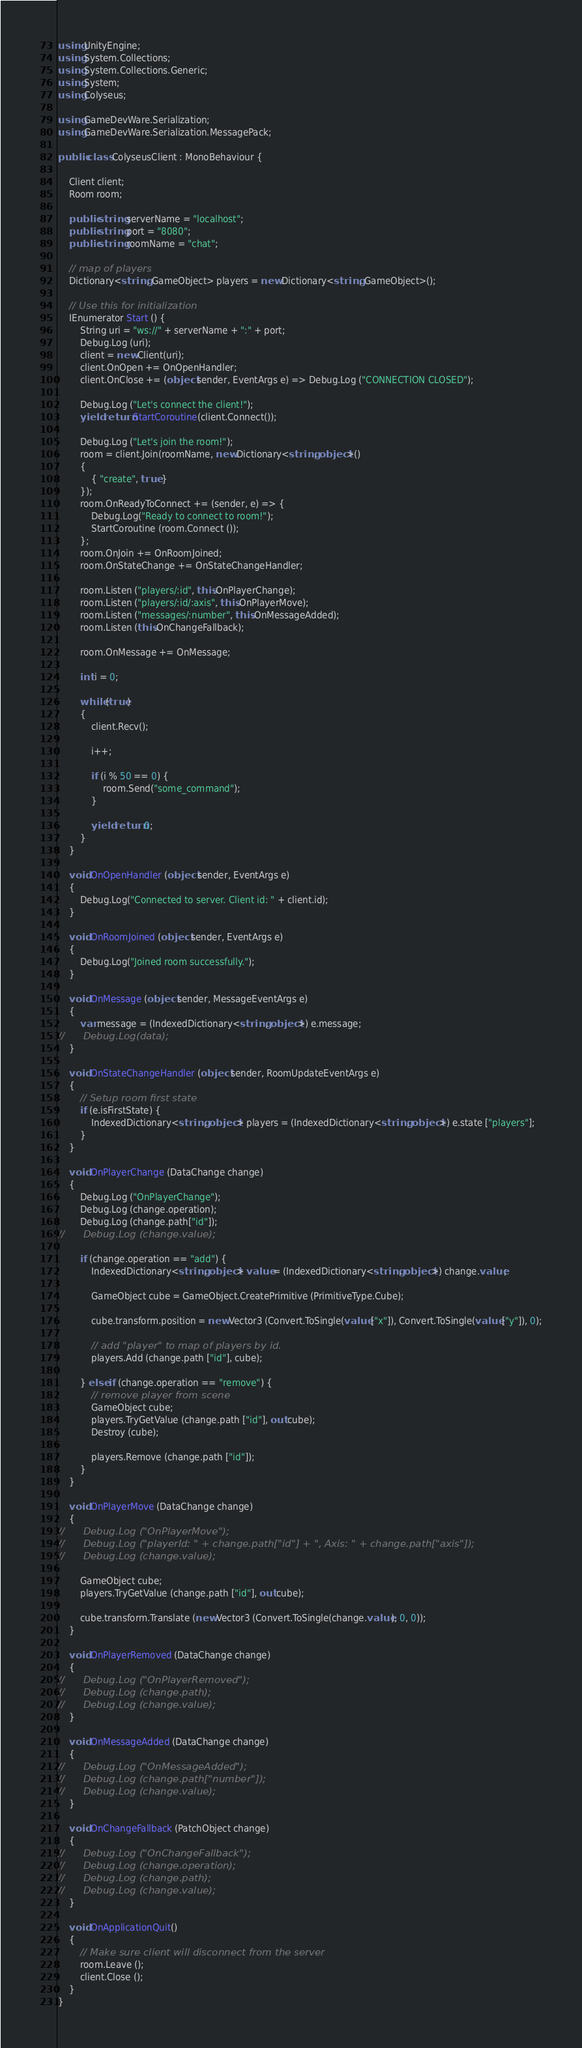Convert code to text. <code><loc_0><loc_0><loc_500><loc_500><_C#_>using UnityEngine;
using System.Collections;
using System.Collections.Generic;
using System;
using Colyseus;

using GameDevWare.Serialization;
using GameDevWare.Serialization.MessagePack;

public class ColyseusClient : MonoBehaviour {

	Client client;
	Room room;

	public string serverName = "localhost";
	public string port = "8080";
	public string roomName = "chat";

	// map of players
	Dictionary<string, GameObject> players = new Dictionary<string, GameObject>();

	// Use this for initialization
	IEnumerator Start () {
		String uri = "ws://" + serverName + ":" + port;
		Debug.Log (uri);
		client = new Client(uri);
		client.OnOpen += OnOpenHandler;
		client.OnClose += (object sender, EventArgs e) => Debug.Log ("CONNECTION CLOSED");

		Debug.Log ("Let's connect the client!");
		yield return StartCoroutine(client.Connect());

		Debug.Log ("Let's join the room!");
		room = client.Join(roomName, new Dictionary<string, object>()
		{
			{ "create", true }
		});
		room.OnReadyToConnect += (sender, e) => {
			Debug.Log("Ready to connect to room!");
			StartCoroutine (room.Connect ());
		};
		room.OnJoin += OnRoomJoined;
		room.OnStateChange += OnStateChangeHandler;

		room.Listen ("players/:id", this.OnPlayerChange);
		room.Listen ("players/:id/:axis", this.OnPlayerMove);
		room.Listen ("messages/:number", this.OnMessageAdded);
		room.Listen (this.OnChangeFallback);

		room.OnMessage += OnMessage;

		int i = 0;

		while (true)
		{
			client.Recv();

			i++;

			if (i % 50 == 0) {
				room.Send("some_command");
			}

			yield return 0;
		}
	}

	void OnOpenHandler (object sender, EventArgs e)
	{
		Debug.Log("Connected to server. Client id: " + client.id);
	}

	void OnRoomJoined (object sender, EventArgs e)
	{
		Debug.Log("Joined room successfully.");
	}

	void OnMessage (object sender, MessageEventArgs e)
	{
		var message = (IndexedDictionary<string, object>) e.message;
//		Debug.Log(data);
	}

	void OnStateChangeHandler (object sender, RoomUpdateEventArgs e)
	{
		// Setup room first state
		if (e.isFirstState) {
			IndexedDictionary<string, object> players = (IndexedDictionary<string, object>) e.state ["players"];
		}
	}

	void OnPlayerChange (DataChange change)
	{
		Debug.Log ("OnPlayerChange");
		Debug.Log (change.operation);
		Debug.Log (change.path["id"]);
//		Debug.Log (change.value);

		if (change.operation == "add") {
			IndexedDictionary<string, object> value = (IndexedDictionary<string, object>) change.value;

			GameObject cube = GameObject.CreatePrimitive (PrimitiveType.Cube);

			cube.transform.position = new Vector3 (Convert.ToSingle(value ["x"]), Convert.ToSingle(value ["y"]), 0);

			// add "player" to map of players by id.
			players.Add (change.path ["id"], cube);

		} else if (change.operation == "remove") {
			// remove player from scene
			GameObject cube;
			players.TryGetValue (change.path ["id"], out cube);
			Destroy (cube);

			players.Remove (change.path ["id"]);
		}
	}

	void OnPlayerMove (DataChange change)
	{
//		Debug.Log ("OnPlayerMove");
//		Debug.Log ("playerId: " + change.path["id"] + ", Axis: " + change.path["axis"]);
//		Debug.Log (change.value);

		GameObject cube;
		players.TryGetValue (change.path ["id"], out cube);

		cube.transform.Translate (new Vector3 (Convert.ToSingle(change.value), 0, 0));
	}

	void OnPlayerRemoved (DataChange change)
	{
//		Debug.Log ("OnPlayerRemoved");
//		Debug.Log (change.path);
//		Debug.Log (change.value);
	}

	void OnMessageAdded (DataChange change)
	{
//		Debug.Log ("OnMessageAdded");
//		Debug.Log (change.path["number"]);
//		Debug.Log (change.value);
	}

	void OnChangeFallback (PatchObject change)
	{
//		Debug.Log ("OnChangeFallback");
//		Debug.Log (change.operation);
//		Debug.Log (change.path);
//		Debug.Log (change.value);
	}

	void OnApplicationQuit()
	{
		// Make sure client will disconnect from the server
		room.Leave ();
		client.Close ();
	}
}
</code> 